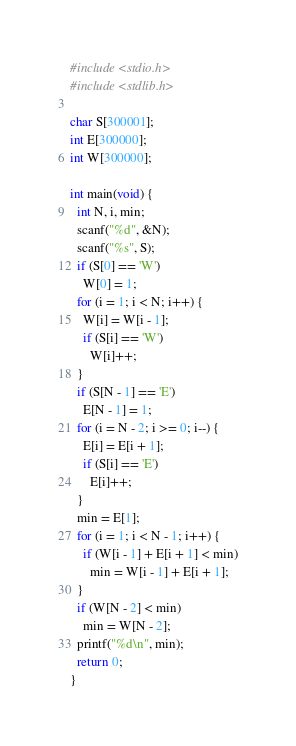Convert code to text. <code><loc_0><loc_0><loc_500><loc_500><_C_>#include <stdio.h>
#include <stdlib.h>

char S[300001];
int E[300000];
int W[300000];

int main(void) {
  int N, i, min;
  scanf("%d", &N);
  scanf("%s", S);
  if (S[0] == 'W')
    W[0] = 1;
  for (i = 1; i < N; i++) {
    W[i] = W[i - 1];
    if (S[i] == 'W')
      W[i]++;
  }
  if (S[N - 1] == 'E')
    E[N - 1] = 1;
  for (i = N - 2; i >= 0; i--) {
    E[i] = E[i + 1];
    if (S[i] == 'E')
      E[i]++;
  }
  min = E[1];
  for (i = 1; i < N - 1; i++) {
    if (W[i - 1] + E[i + 1] < min)
      min = W[i - 1] + E[i + 1];
  }
  if (W[N - 2] < min)
    min = W[N - 2];
  printf("%d\n", min);
  return 0;
}</code> 